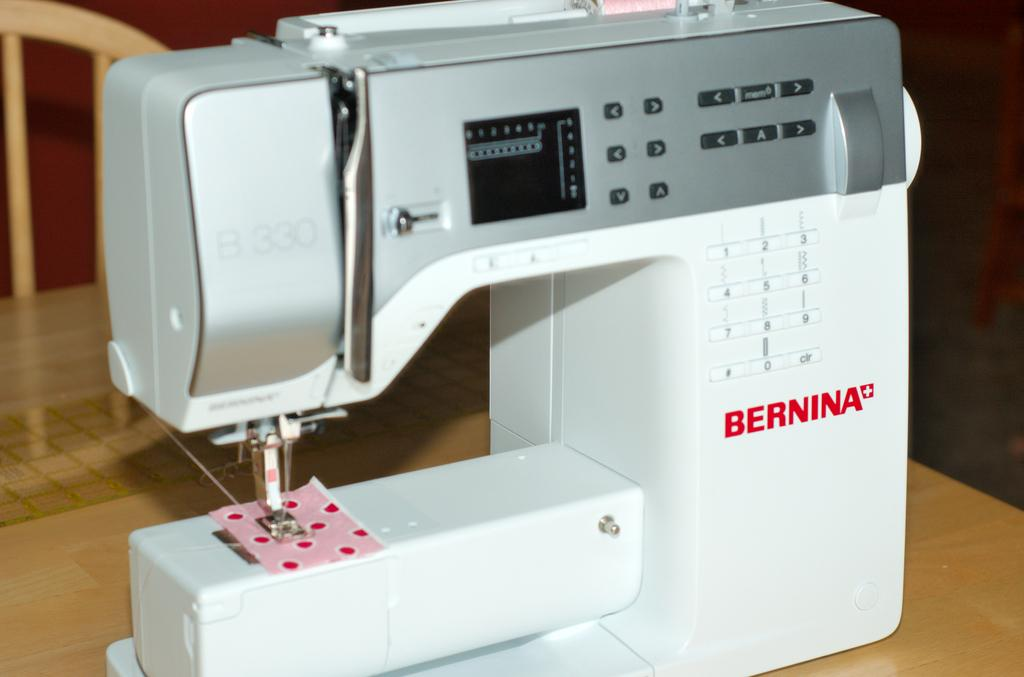What is the main object in the image? There is a machine in the image. What colors are used for the machine? The machine is in white and ash color. On what surface is the machine placed? The machine is on a brown color table. What type of furniture is present in the image? There is a wooden chair in the image. What time of day is depicted in the image? The time of day is not mentioned or depicted in the image. How many pins are attached to the machine in the image? There are no pins present or attached to the machine in the image. 